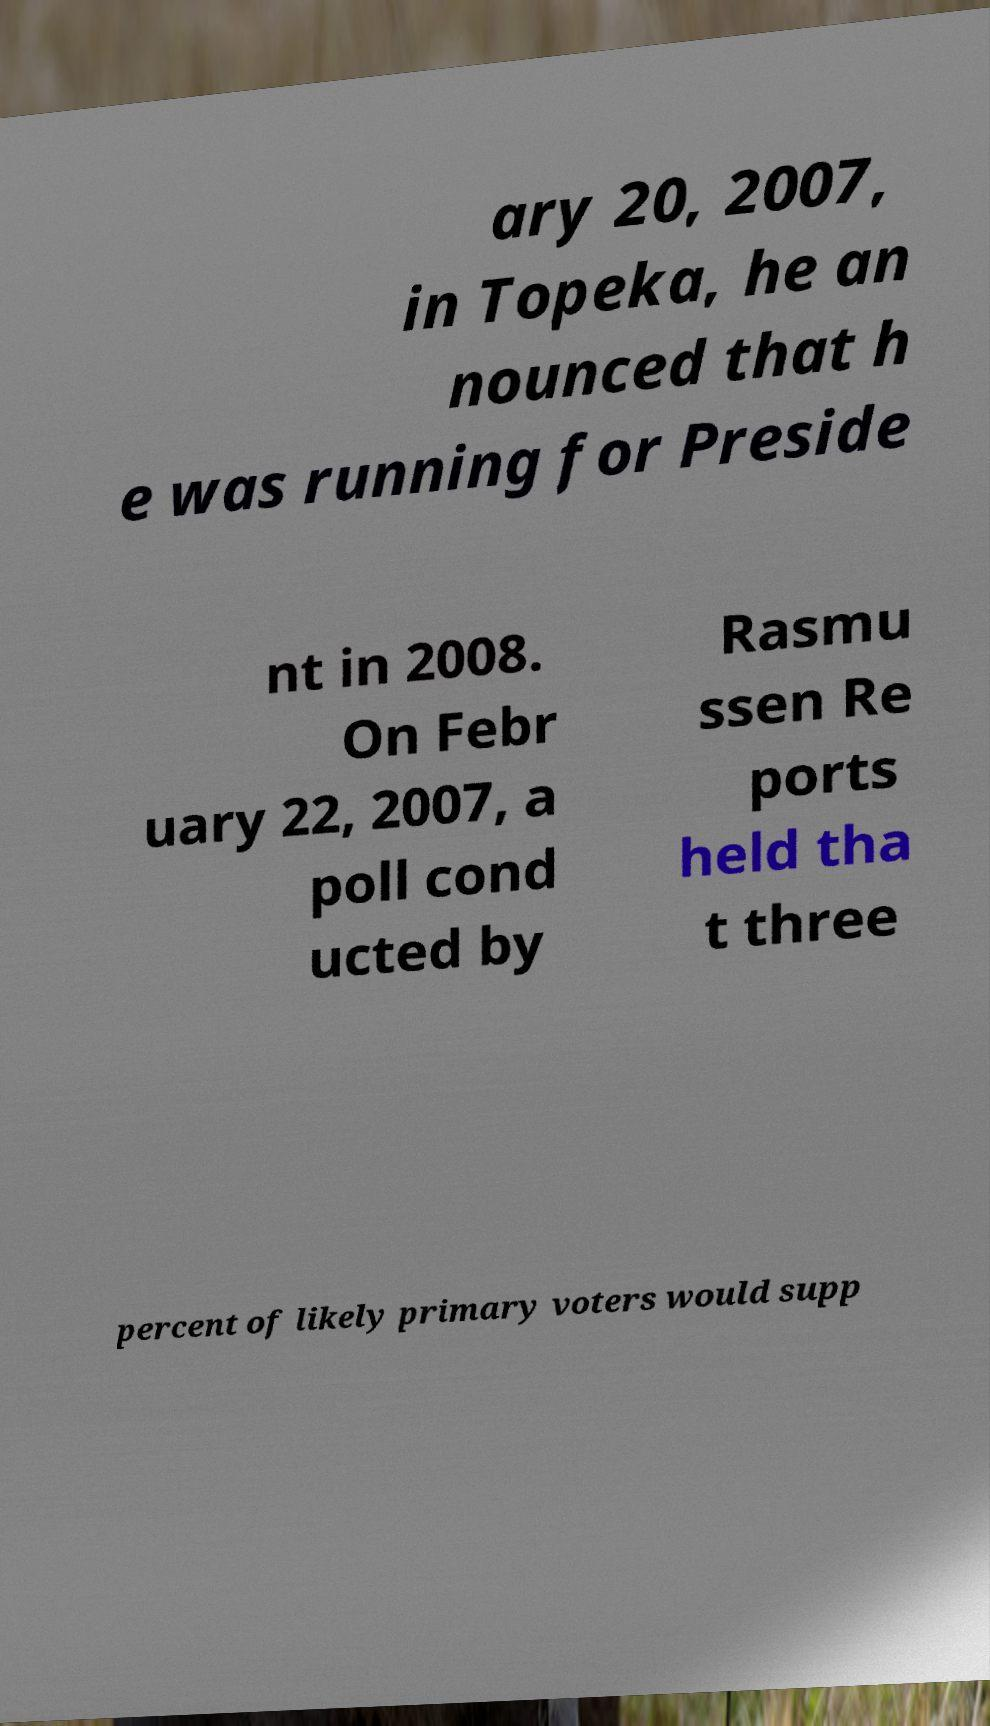There's text embedded in this image that I need extracted. Can you transcribe it verbatim? ary 20, 2007, in Topeka, he an nounced that h e was running for Preside nt in 2008. On Febr uary 22, 2007, a poll cond ucted by Rasmu ssen Re ports held tha t three percent of likely primary voters would supp 